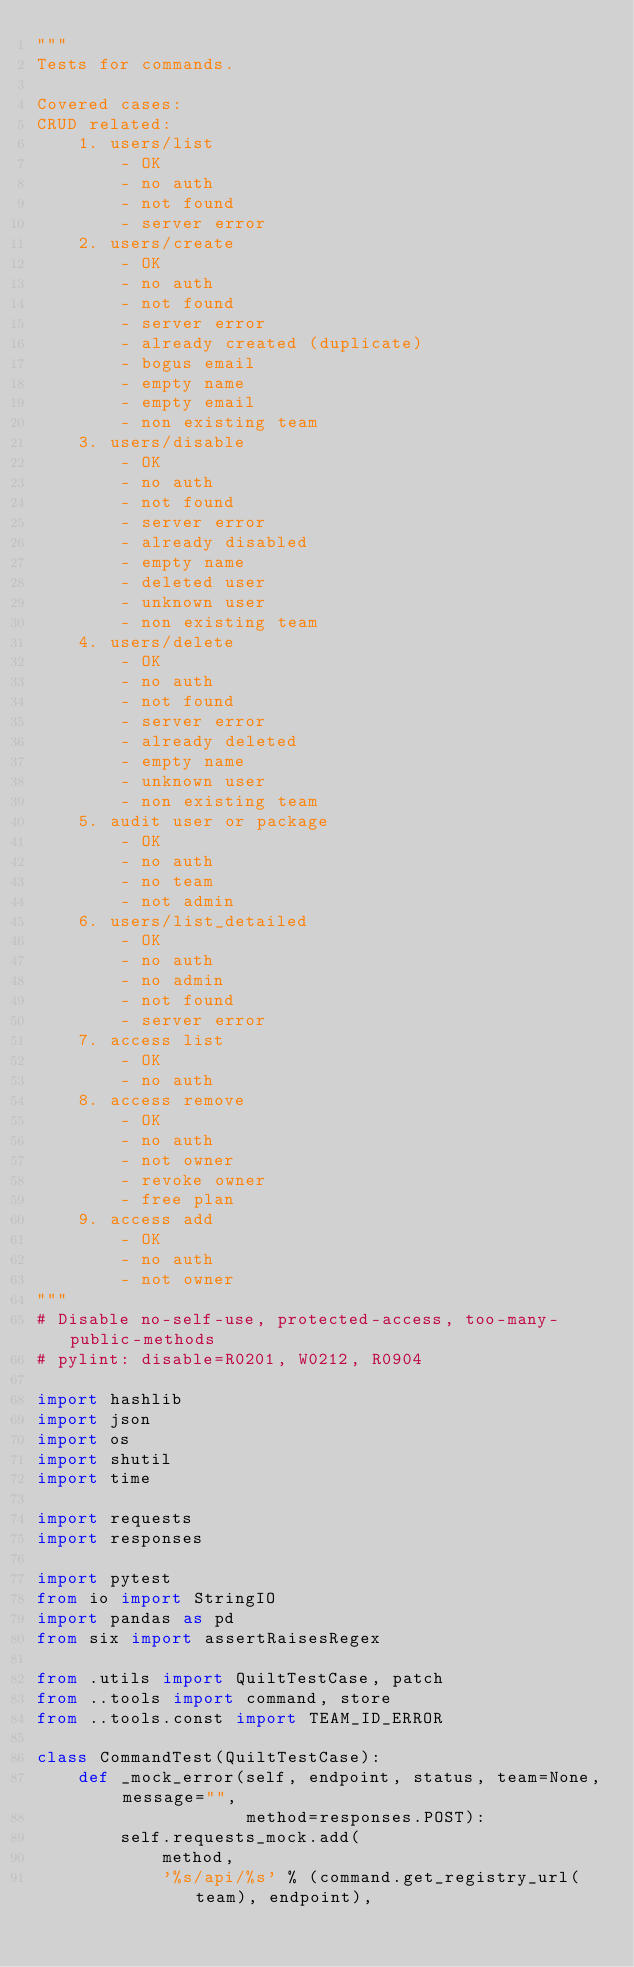<code> <loc_0><loc_0><loc_500><loc_500><_Python_>"""
Tests for commands.

Covered cases:
CRUD related:
    1. users/list
        - OK
        - no auth
        - not found
        - server error
    2. users/create
        - OK
        - no auth
        - not found
        - server error
        - already created (duplicate)
        - bogus email
        - empty name
        - empty email
        - non existing team
    3. users/disable
        - OK
        - no auth
        - not found
        - server error
        - already disabled
        - empty name
        - deleted user
        - unknown user
        - non existing team
    4. users/delete
        - OK
        - no auth
        - not found
        - server error
        - already deleted
        - empty name
        - unknown user
        - non existing team
    5. audit user or package
        - OK
        - no auth
        - no team
        - not admin
    6. users/list_detailed
        - OK
        - no auth
        - no admin
        - not found
        - server error
    7. access list
        - OK
        - no auth
    8. access remove
        - OK
        - no auth
        - not owner
        - revoke owner
        - free plan
    9. access add
        - OK
        - no auth
        - not owner
"""
# Disable no-self-use, protected-access, too-many-public-methods
# pylint: disable=R0201, W0212, R0904

import hashlib
import json
import os
import shutil
import time

import requests
import responses

import pytest
from io import StringIO
import pandas as pd
from six import assertRaisesRegex

from .utils import QuiltTestCase, patch
from ..tools import command, store
from ..tools.const import TEAM_ID_ERROR

class CommandTest(QuiltTestCase):
    def _mock_error(self, endpoint, status, team=None, message="",
                    method=responses.POST):
        self.requests_mock.add(
            method,
            '%s/api/%s' % (command.get_registry_url(team), endpoint),</code> 